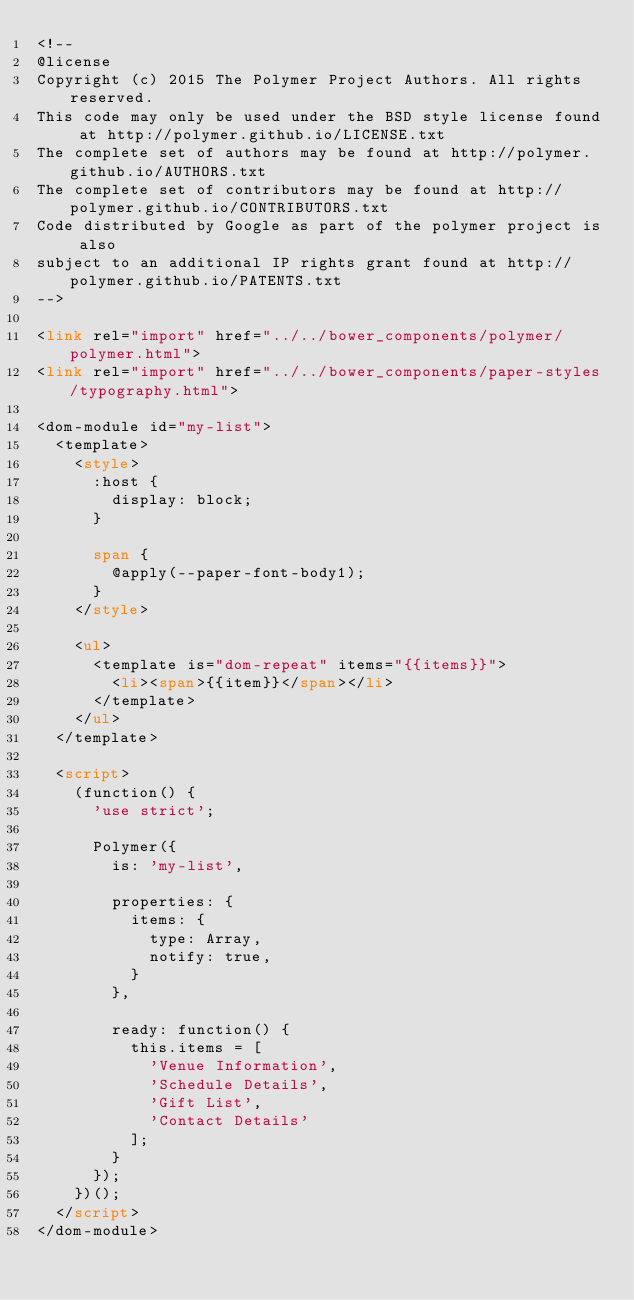Convert code to text. <code><loc_0><loc_0><loc_500><loc_500><_HTML_><!--
@license
Copyright (c) 2015 The Polymer Project Authors. All rights reserved.
This code may only be used under the BSD style license found at http://polymer.github.io/LICENSE.txt
The complete set of authors may be found at http://polymer.github.io/AUTHORS.txt
The complete set of contributors may be found at http://polymer.github.io/CONTRIBUTORS.txt
Code distributed by Google as part of the polymer project is also
subject to an additional IP rights grant found at http://polymer.github.io/PATENTS.txt
-->

<link rel="import" href="../../bower_components/polymer/polymer.html">
<link rel="import" href="../../bower_components/paper-styles/typography.html">

<dom-module id="my-list">
  <template>
    <style>
      :host {
        display: block;
      }

      span {
        @apply(--paper-font-body1);
      }
    </style>

    <ul>
      <template is="dom-repeat" items="{{items}}">
        <li><span>{{item}}</span></li>
      </template>
    </ul>
  </template>

  <script>
    (function() {
      'use strict';

      Polymer({
        is: 'my-list',

        properties: {
          items: {
            type: Array,
            notify: true,
          }
        },

        ready: function() {
          this.items = [
            'Venue Information',
            'Schedule Details',
            'Gift List',
            'Contact Details'
          ];
        }
      });
    })();
  </script>
</dom-module>
</code> 